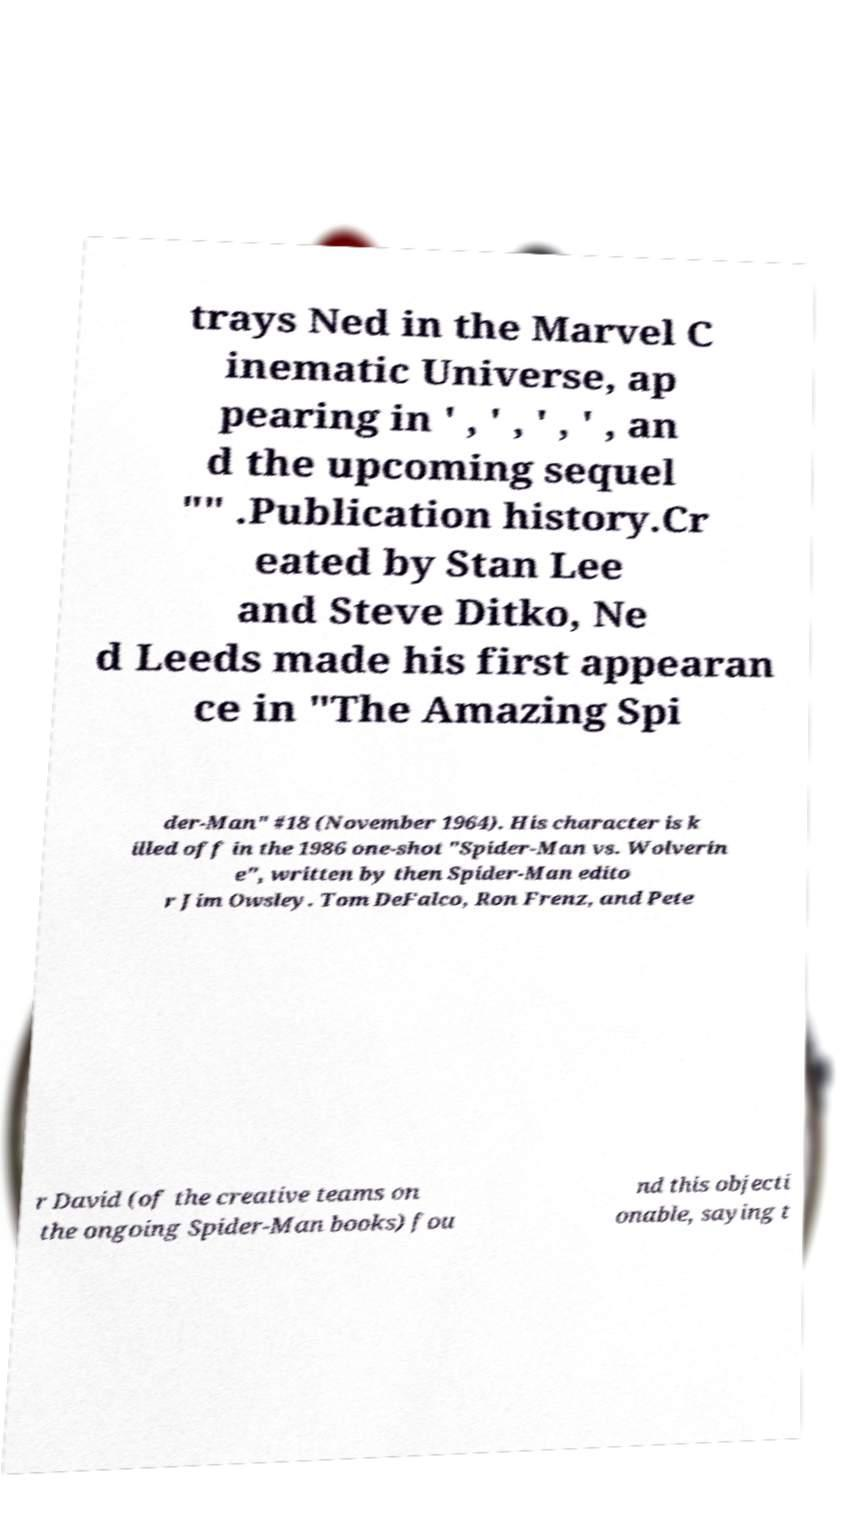There's text embedded in this image that I need extracted. Can you transcribe it verbatim? trays Ned in the Marvel C inematic Universe, ap pearing in ' , ' , ' , ' , an d the upcoming sequel "" .Publication history.Cr eated by Stan Lee and Steve Ditko, Ne d Leeds made his first appearan ce in "The Amazing Spi der-Man" #18 (November 1964). His character is k illed off in the 1986 one-shot "Spider-Man vs. Wolverin e", written by then Spider-Man edito r Jim Owsley. Tom DeFalco, Ron Frenz, and Pete r David (of the creative teams on the ongoing Spider-Man books) fou nd this objecti onable, saying t 